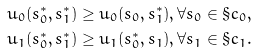<formula> <loc_0><loc_0><loc_500><loc_500>u _ { 0 } ( s _ { 0 } ^ { * } , s _ { 1 } ^ { * } ) \geq u _ { 0 } ( s _ { 0 } , s _ { 1 } ^ { * } ) , \forall s _ { 0 } \in \S c _ { 0 } , \\ u _ { 1 } ( s _ { 0 } ^ { * } , s _ { 1 } ^ { * } ) \geq u _ { 1 } ( s _ { 0 } ^ { * } , s _ { 1 } ) , \forall s _ { 1 } \in \S c _ { 1 } .</formula> 